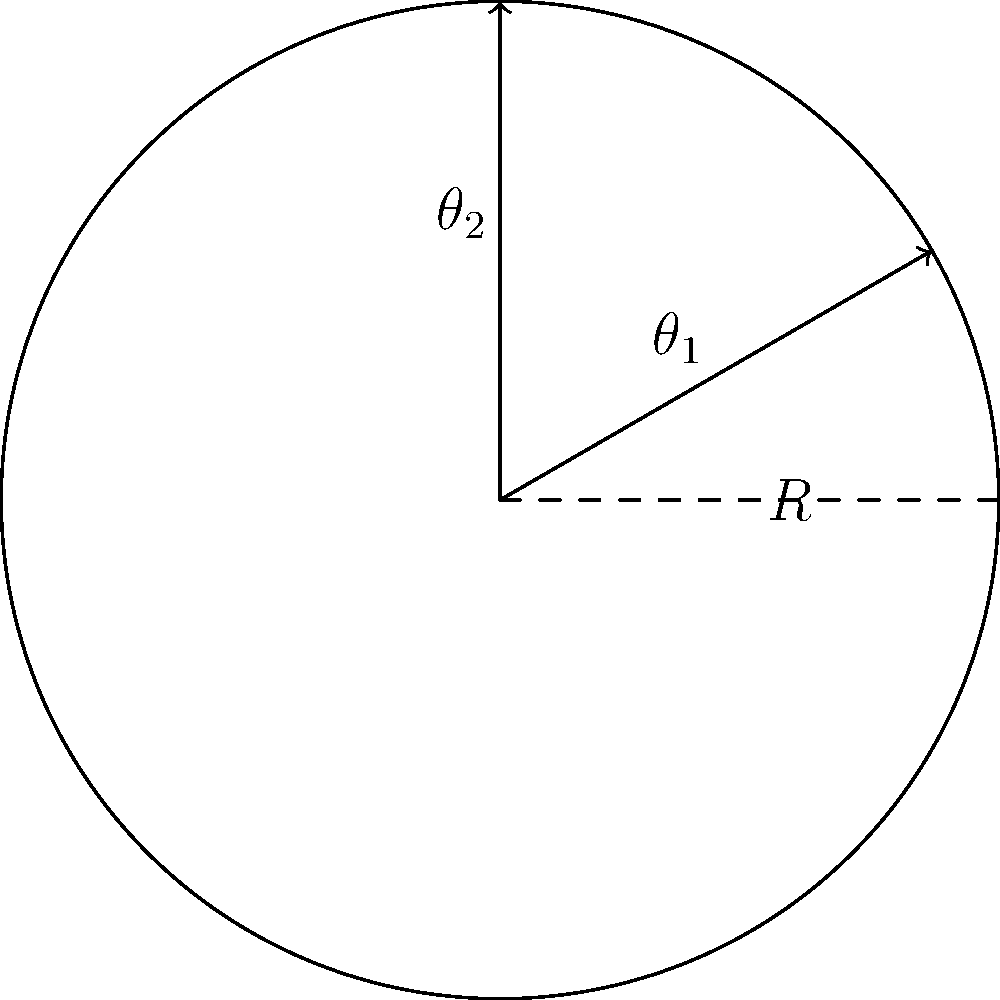At the Neftohimik Stadium in Burgas, a circular section has a radius of 30 meters. If fans occupy the area between $\theta_1 = \frac{\pi}{6}$ and $\theta_2 = \frac{\pi}{2}$ radians, what is the area (in square meters) covered by the fans? Use the formula for area in polar coordinates: $A = \frac{1}{2} \int_{\theta_1}^{\theta_2} r^2 d\theta$. Let's solve this step-by-step:

1) We are given:
   - Radius $R = 30$ meters
   - $\theta_1 = \frac{\pi}{6}$
   - $\theta_2 = \frac{\pi}{2}$

2) The formula for area in polar coordinates is:
   $A = \frac{1}{2} \int_{\theta_1}^{\theta_2} r^2 d\theta$

3) In this case, $r$ is constant and equal to $R$, so we can take it out of the integral:
   $A = \frac{1}{2} R^2 \int_{\theta_1}^{\theta_2} d\theta$

4) Integrate:
   $A = \frac{1}{2} R^2 [\theta]_{\theta_1}^{\theta_2} = \frac{1}{2} R^2 (\theta_2 - \theta_1)$

5) Substitute the values:
   $A = \frac{1}{2} (30)^2 (\frac{\pi}{2} - \frac{\pi}{6})$

6) Simplify:
   $A = 450 (\frac{\pi}{3}) = 150\pi$

Therefore, the area covered by the fans is $150\pi$ square meters.
Answer: $150\pi$ m² 